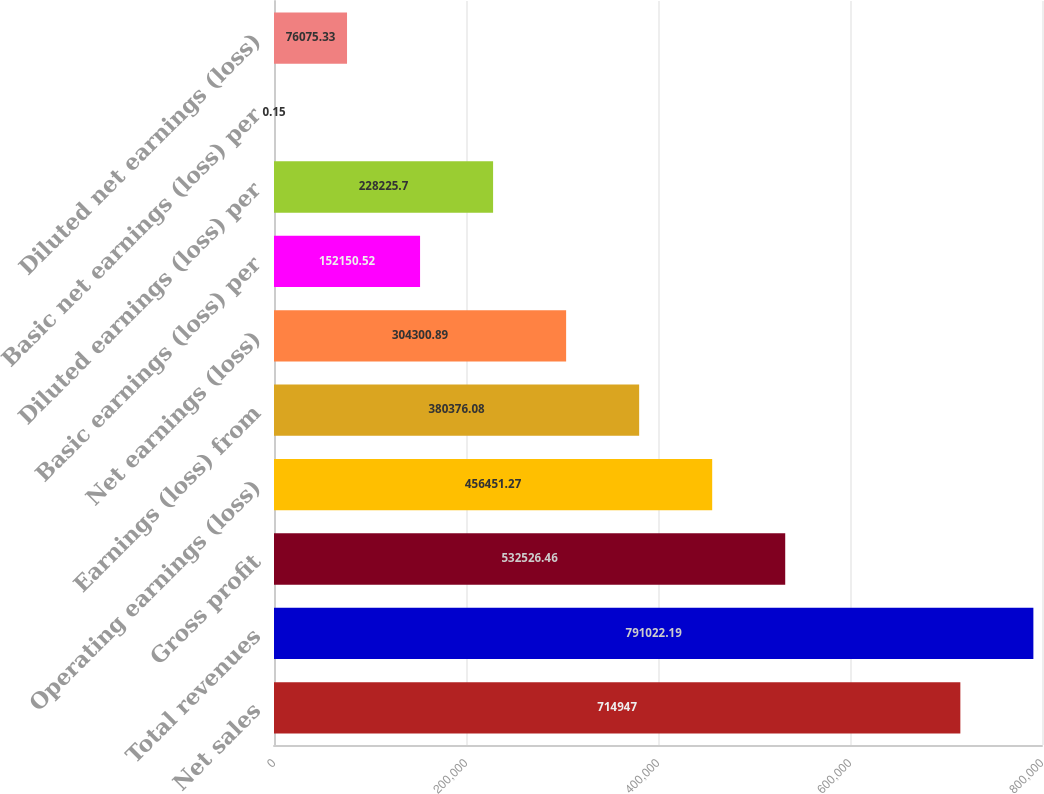<chart> <loc_0><loc_0><loc_500><loc_500><bar_chart><fcel>Net sales<fcel>Total revenues<fcel>Gross profit<fcel>Operating earnings (loss)<fcel>Earnings (loss) from<fcel>Net earnings (loss)<fcel>Basic earnings (loss) per<fcel>Diluted earnings (loss) per<fcel>Basic net earnings (loss) per<fcel>Diluted net earnings (loss)<nl><fcel>714947<fcel>791022<fcel>532526<fcel>456451<fcel>380376<fcel>304301<fcel>152151<fcel>228226<fcel>0.15<fcel>76075.3<nl></chart> 